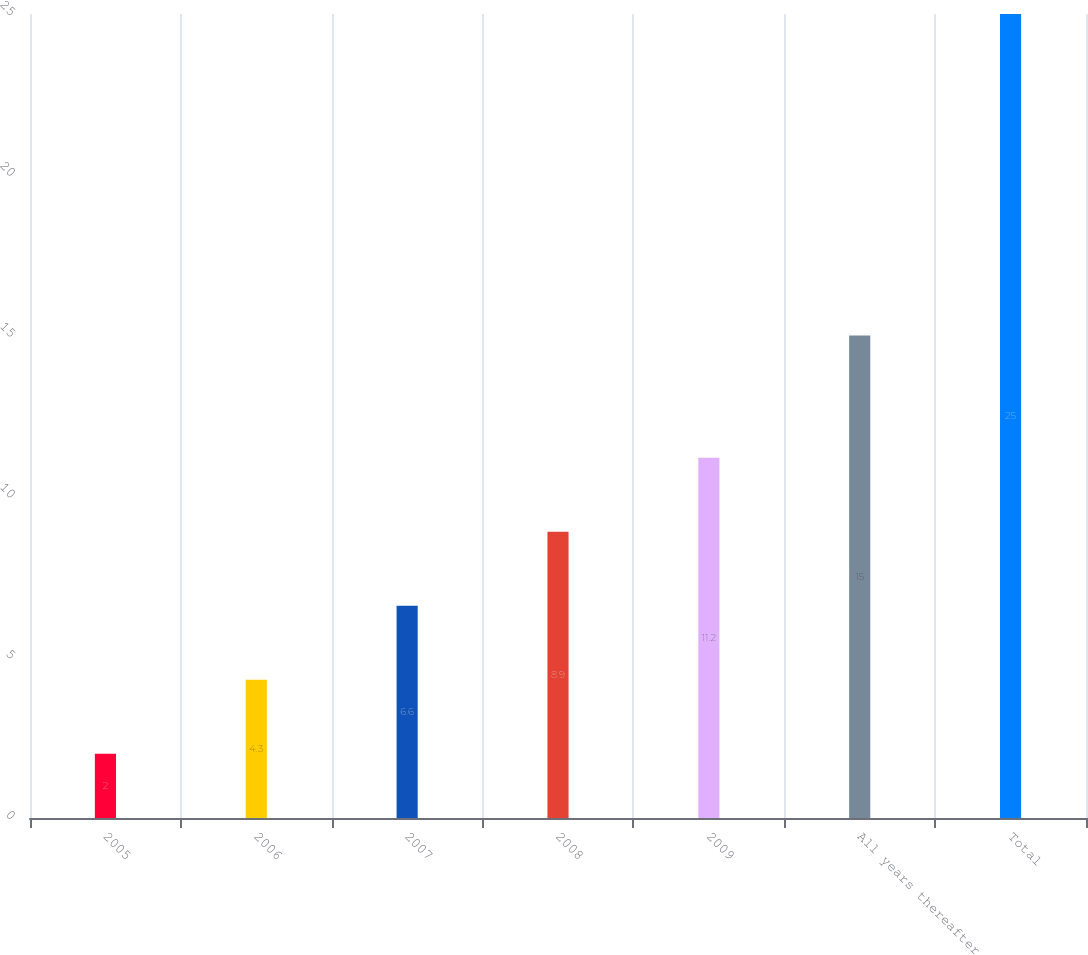Convert chart. <chart><loc_0><loc_0><loc_500><loc_500><bar_chart><fcel>2005<fcel>2006<fcel>2007<fcel>2008<fcel>2009<fcel>All years thereafter<fcel>Total<nl><fcel>2<fcel>4.3<fcel>6.6<fcel>8.9<fcel>11.2<fcel>15<fcel>25<nl></chart> 